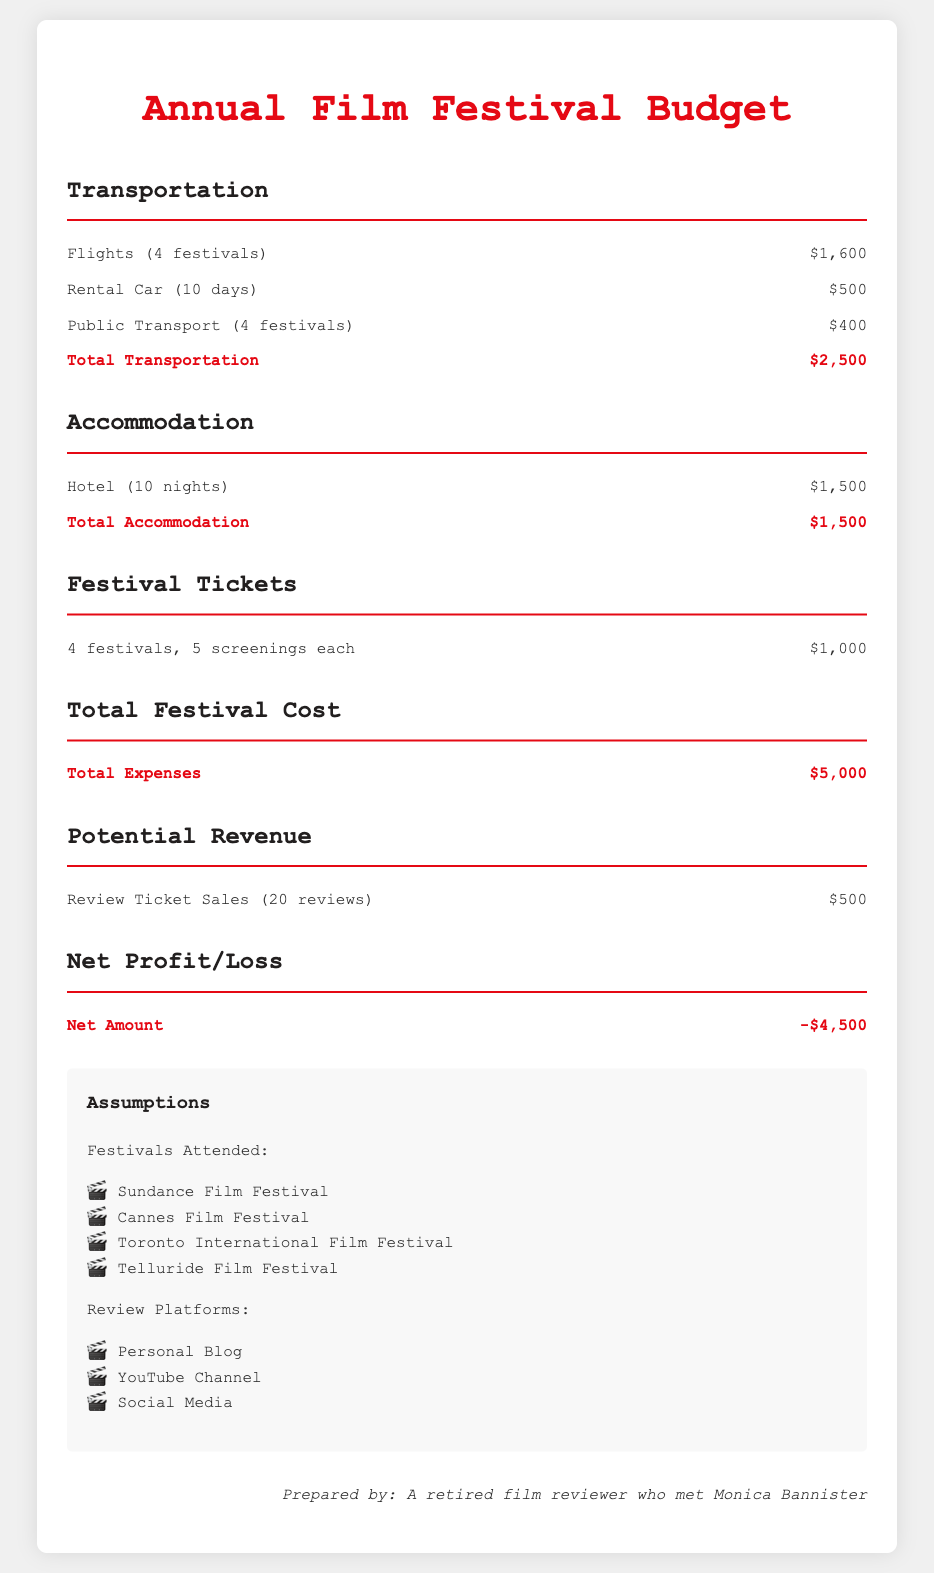What is the total transportation cost? The total transportation cost is the sum of flights, rental car, and public transport costs, which is $1,600 + $500 + $400 = $2,500.
Answer: $2,500 How many film festivals are being attended? The document mentions attending four film festivals.
Answer: 4 What is the cost for hotel accommodation? The cost for hotel accommodation is listed as $1,500 for ten nights.
Answer: $1,500 What is the total expense for attending the festivals? The total expense is calculated as the sum of transportation, accommodation, and ticket costs, amounting to $5,000.
Answer: $5,000 What is the potential revenue from review ticket sales? The potential revenue from review ticket sales is stated as $500 for 20 reviews.
Answer: $500 What is the net amount presented in the budget? The net amount is calculated as total revenue minus total expenses, resulting in -$4,500.
Answer: -$4,500 How many screenings are included in the ticket cost? Each festival includes five screenings, with a total of four festivals attended.
Answer: 5 What are the review platforms mentioned? The document lists personal blog, YouTube channel, and social media as review platforms.
Answer: Personal Blog, YouTube Channel, Social Media What is the total accommodation expense? The total accommodation expense is given as $1,500 for ten nights.
Answer: $1,500 What is the transportation method with the highest cost? The transportation method with the highest cost is flights, totaling $1,600.
Answer: Flights 